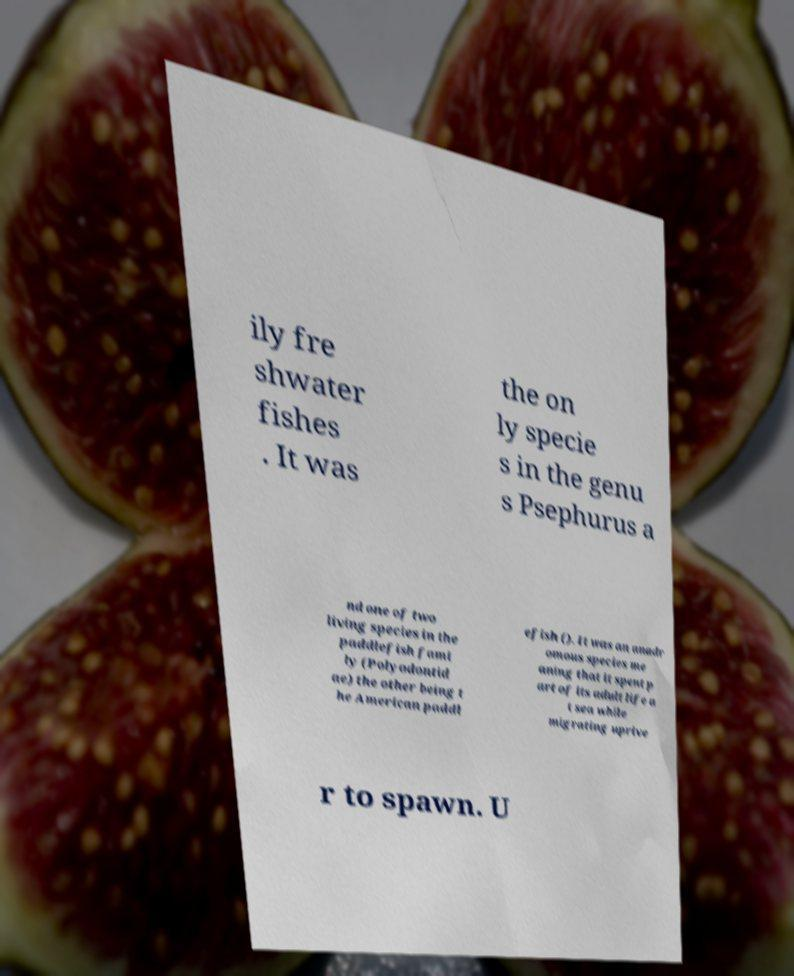Please read and relay the text visible in this image. What does it say? ily fre shwater fishes . It was the on ly specie s in the genu s Psephurus a nd one of two living species in the paddlefish fami ly (Polyodontid ae) the other being t he American paddl efish (). It was an anadr omous species me aning that it spent p art of its adult life a t sea while migrating uprive r to spawn. U 